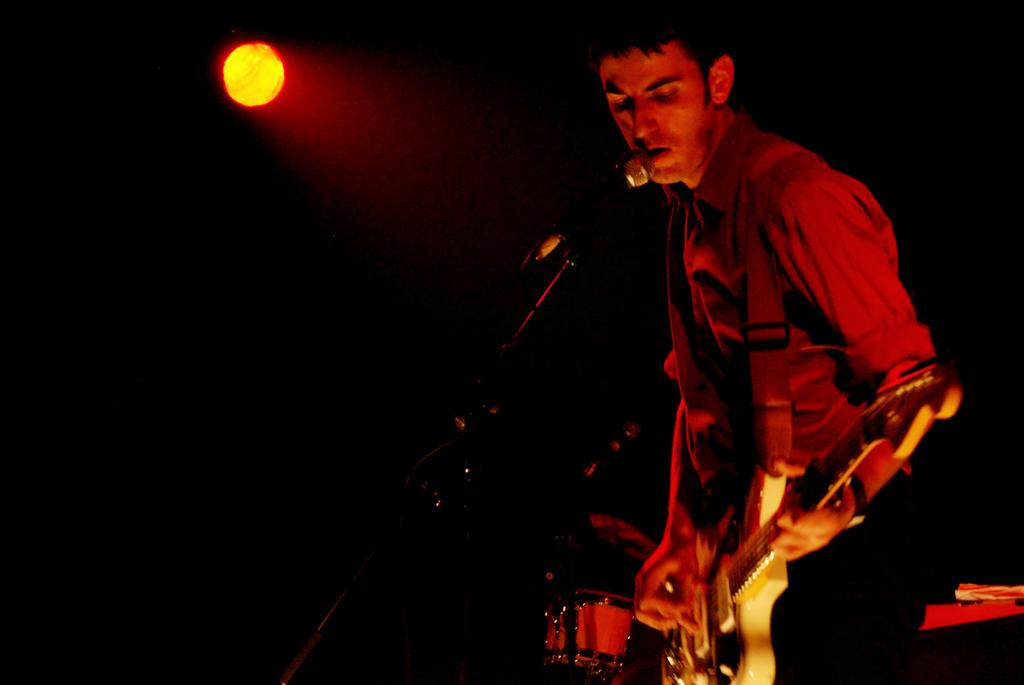Who is the main subject in the image? There is a boy in the image. Where is the boy positioned in the image? The boy is standing at the right side of the image. What is the boy holding in his hands? The boy is holding a guitar in his hands. What object is present at the left side of the image? There is a microphone at the left side of the image. What type of tomatoes can be seen growing in the image? There are no tomatoes present in the image; it features a boy holding a guitar and a microphone at the left side. Is there a club visible in the image? There is no club present in the image. 